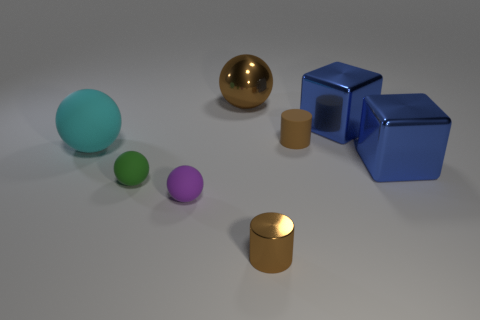Add 2 small green metallic spheres. How many objects exist? 10 Subtract all cylinders. How many objects are left? 6 Add 4 small spheres. How many small spheres are left? 6 Add 6 brown metal cylinders. How many brown metal cylinders exist? 7 Subtract 0 green cylinders. How many objects are left? 8 Subtract all small spheres. Subtract all green spheres. How many objects are left? 5 